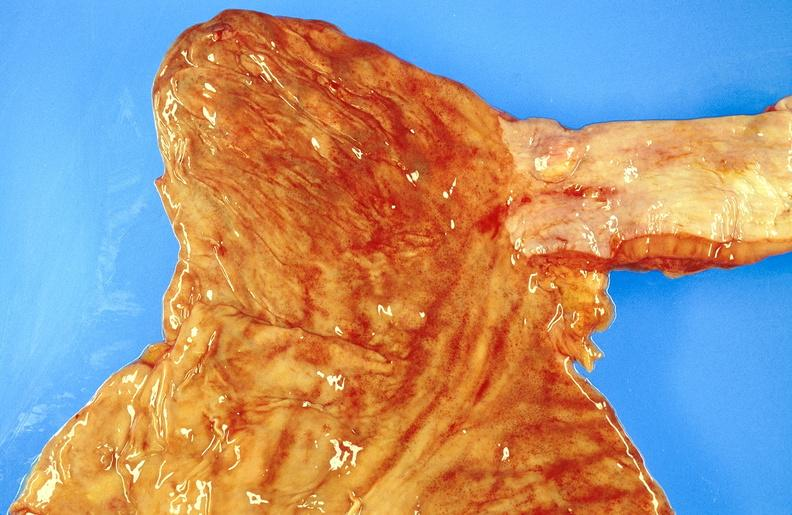does natural color show esophagus, leiomyoma?
Answer the question using a single word or phrase. No 